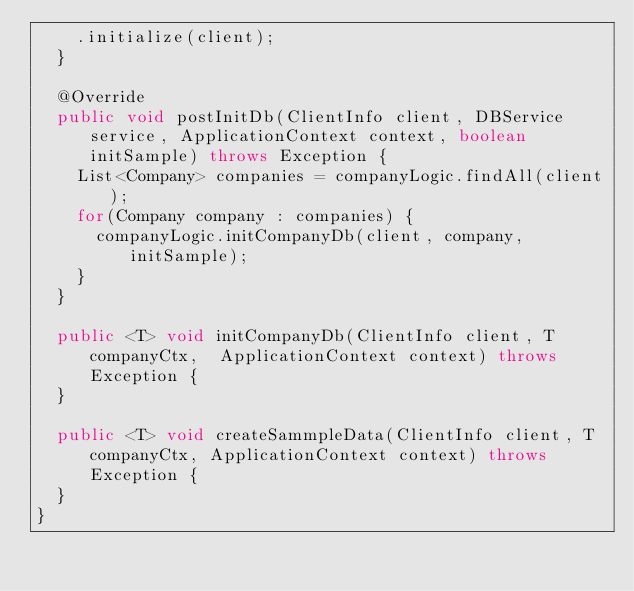Convert code to text. <code><loc_0><loc_0><loc_500><loc_500><_Java_>    .initialize(client);
  }
  
  @Override
  public void postInitDb(ClientInfo client, DBService service, ApplicationContext context, boolean initSample) throws Exception {
    List<Company> companies = companyLogic.findAll(client);
    for(Company company : companies) {
      companyLogic.initCompanyDb(client, company, initSample);
    }
  }

  public <T> void initCompanyDb(ClientInfo client, T companyCtx,  ApplicationContext context) throws Exception {
  }
  
  public <T> void createSammpleData(ClientInfo client, T companyCtx, ApplicationContext context) throws Exception {
  }
}
</code> 